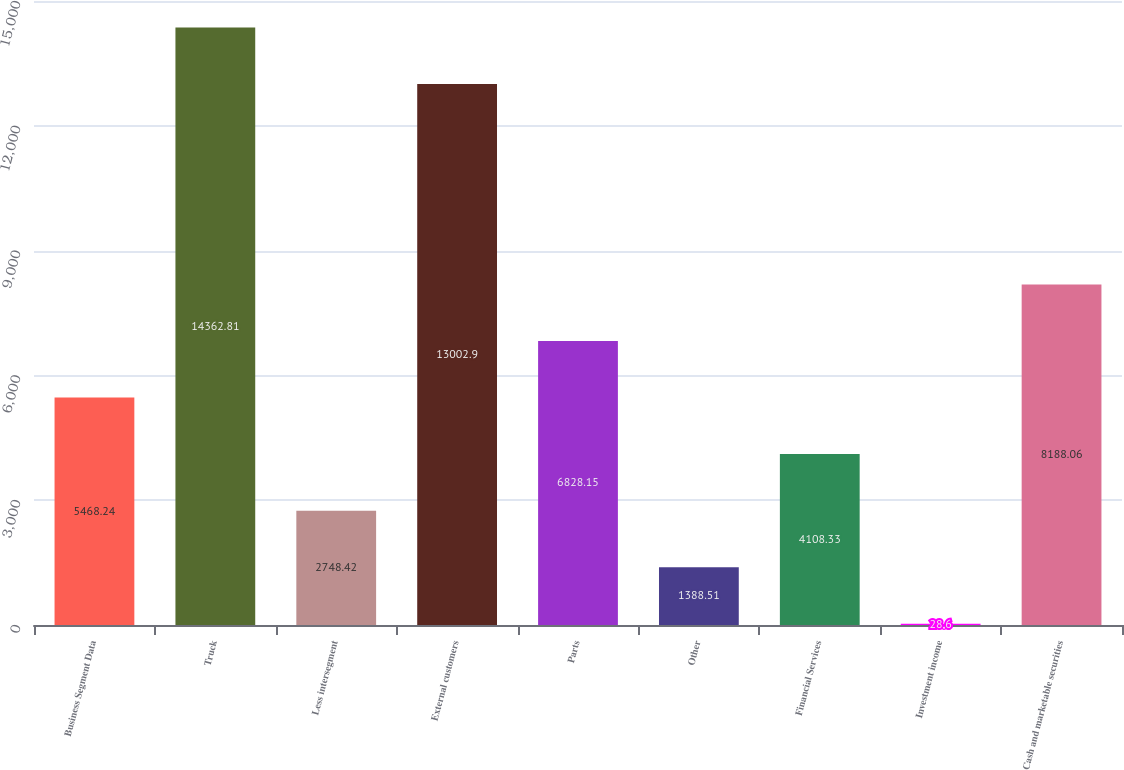Convert chart to OTSL. <chart><loc_0><loc_0><loc_500><loc_500><bar_chart><fcel>Business Segment Data<fcel>Truck<fcel>Less intersegment<fcel>External customers<fcel>Parts<fcel>Other<fcel>Financial Services<fcel>Investment income<fcel>Cash and marketable securities<nl><fcel>5468.24<fcel>14362.8<fcel>2748.42<fcel>13002.9<fcel>6828.15<fcel>1388.51<fcel>4108.33<fcel>28.6<fcel>8188.06<nl></chart> 